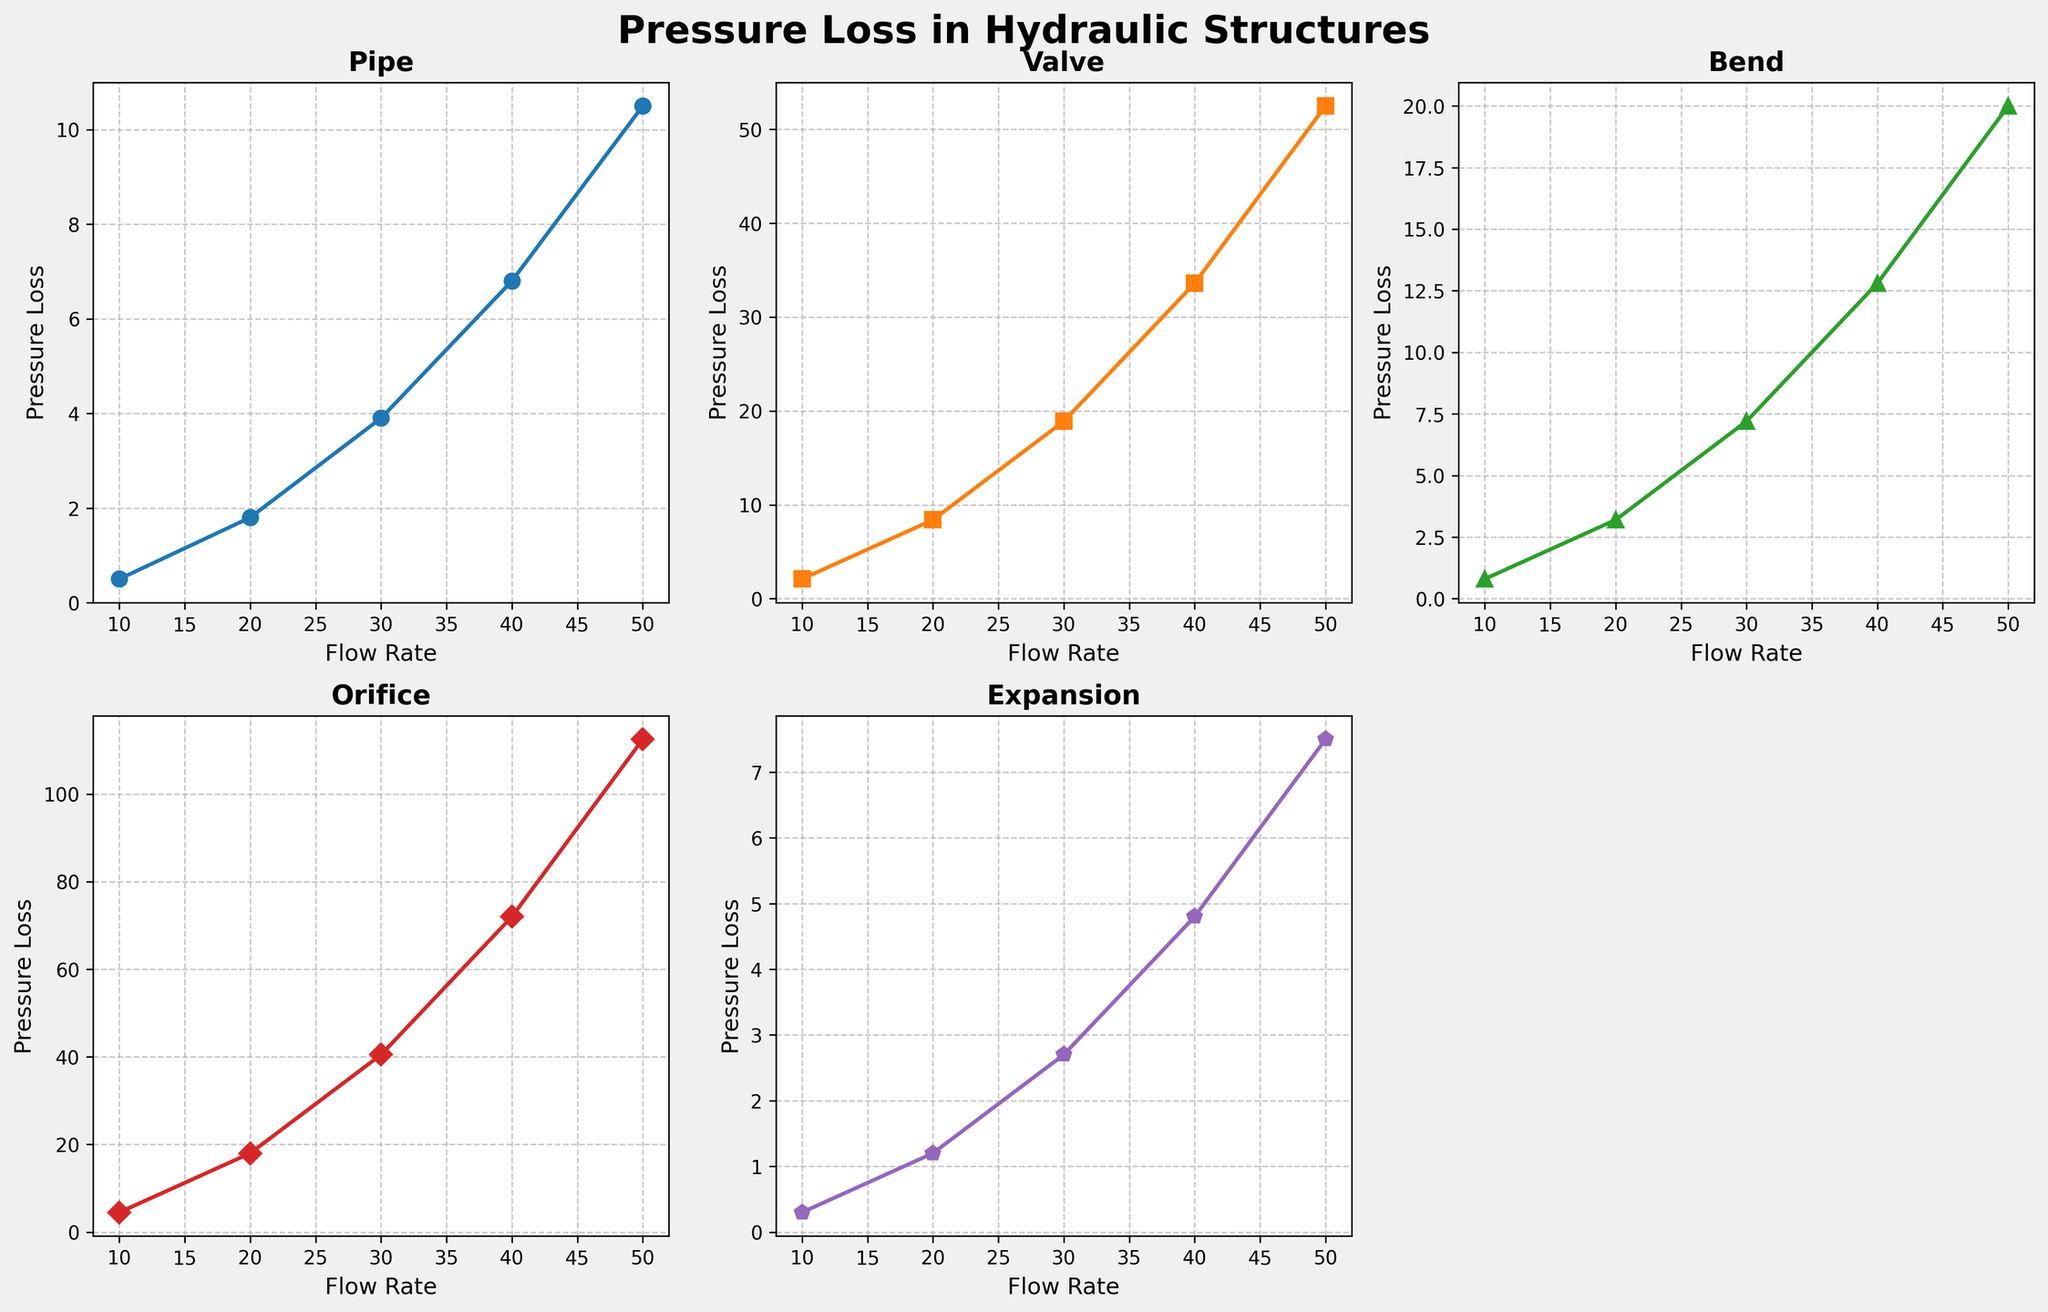Which structure shows the highest pressure loss at a flow rate of 50? To determine this, look at the pressure loss values for each structure at a flow rate of 50 in the plots. The orifice shows the highest pressure loss value at 50.
Answer: orifice How does the pressure loss in a bend compare to that in a valve at a flow rate of 20? Compare the pressure loss value of the bend and the valve at a flow rate of 20 in their respective plots. The bend has a pressure loss of 3.2, while the valve has a pressure loss of 8.4. The valve has a higher pressure loss.
Answer: valve What is the sum of the pressure losses for each structure at a flow rate of 30? Sum the pressure loss values for the pipe, valve, bend, orifice, and expansion at a flow rate of 30: 3.9 (pipe) + 18.9 (valve) + 7.2 (bend) + 40.5 (orifice) + 2.7 (expansion) = 73.2.
Answer: 73.2 Which structure has the steepest slope of pressure loss as flow rate increases? Evaluate the steepness of the lines in the plots for each structure. The orifice has the steepest slope, as indicated by the rapid increase in pressure loss with increasing flow rate.
Answer: orifice What is the average pressure loss for a pipe at flow rates of 10 and 20? Calculate the average of the pressure loss values for the pipe at flow rates of 10 and 20: (0.5 + 1.8) / 2 = 1.15.
Answer: 1.15 How does the shape of the pressure loss curve for an expansion compare to that of a pipe? Compare the curves in the plots for expansion and pipe; both show a relatively gradual increase, but the expansion's curve is flatter.
Answer: expansion curve is flatter Which structure has the lowest pressure loss at a flow rate of 10? Look at the pressure loss values for each structure at a flow rate of 10. The expansion has the lowest pressure loss of 0.3.
Answer: expansion Given the trend, which structure's pressure loss appears to increase quadratically with flow rate? The plots of the valve and orifice show a quadratic-like increase, but the slope for the orifice is more pronounced, indicating a quadratic relationship.
Answer: orifice 